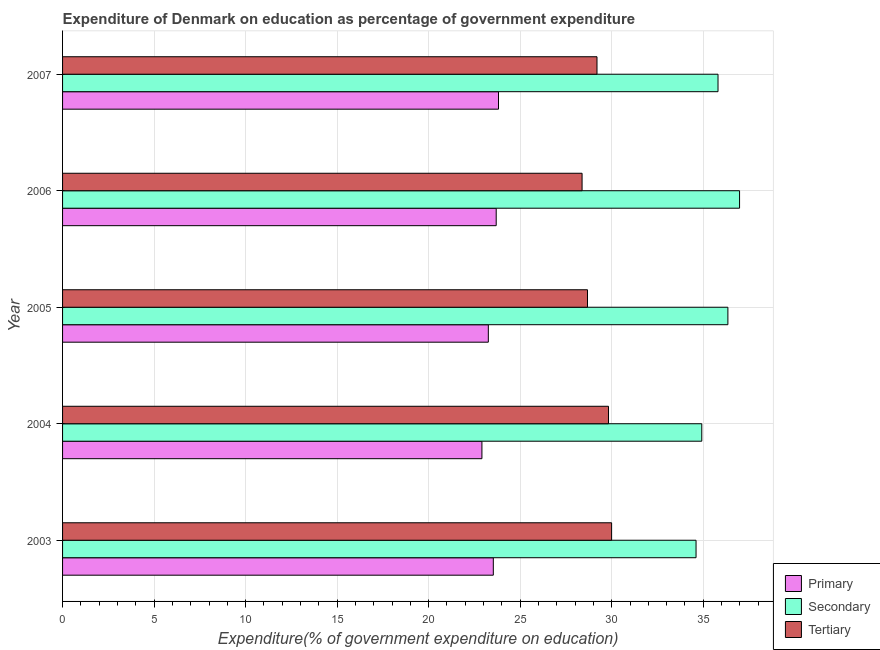Are the number of bars on each tick of the Y-axis equal?
Offer a terse response. Yes. How many bars are there on the 3rd tick from the bottom?
Give a very brief answer. 3. What is the expenditure on secondary education in 2005?
Provide a short and direct response. 36.35. Across all years, what is the maximum expenditure on primary education?
Offer a very short reply. 23.82. Across all years, what is the minimum expenditure on primary education?
Your answer should be compact. 22.91. What is the total expenditure on secondary education in the graph?
Keep it short and to the point. 178.67. What is the difference between the expenditure on secondary education in 2003 and that in 2007?
Ensure brevity in your answer.  -1.2. What is the difference between the expenditure on secondary education in 2007 and the expenditure on tertiary education in 2003?
Provide a succinct answer. 5.81. What is the average expenditure on primary education per year?
Keep it short and to the point. 23.44. In the year 2005, what is the difference between the expenditure on primary education and expenditure on secondary education?
Give a very brief answer. -13.09. In how many years, is the expenditure on primary education greater than 7 %?
Provide a succinct answer. 5. Is the expenditure on secondary education in 2003 less than that in 2005?
Provide a short and direct response. Yes. Is the difference between the expenditure on primary education in 2003 and 2004 greater than the difference between the expenditure on secondary education in 2003 and 2004?
Provide a succinct answer. Yes. What is the difference between the highest and the second highest expenditure on tertiary education?
Your answer should be very brief. 0.17. What is the difference between the highest and the lowest expenditure on secondary education?
Provide a short and direct response. 2.38. Is the sum of the expenditure on primary education in 2003 and 2006 greater than the maximum expenditure on secondary education across all years?
Offer a terse response. Yes. What does the 1st bar from the top in 2006 represents?
Your response must be concise. Tertiary. What does the 2nd bar from the bottom in 2004 represents?
Keep it short and to the point. Secondary. Is it the case that in every year, the sum of the expenditure on primary education and expenditure on secondary education is greater than the expenditure on tertiary education?
Offer a terse response. Yes. How many bars are there?
Keep it short and to the point. 15. Are all the bars in the graph horizontal?
Your answer should be compact. Yes. How many years are there in the graph?
Ensure brevity in your answer.  5. Does the graph contain grids?
Ensure brevity in your answer.  Yes. What is the title of the graph?
Your answer should be very brief. Expenditure of Denmark on education as percentage of government expenditure. Does "Liquid fuel" appear as one of the legend labels in the graph?
Your answer should be very brief. No. What is the label or title of the X-axis?
Offer a terse response. Expenditure(% of government expenditure on education). What is the label or title of the Y-axis?
Provide a short and direct response. Year. What is the Expenditure(% of government expenditure on education) of Primary in 2003?
Make the answer very short. 23.53. What is the Expenditure(% of government expenditure on education) of Secondary in 2003?
Ensure brevity in your answer.  34.61. What is the Expenditure(% of government expenditure on education) of Tertiary in 2003?
Provide a short and direct response. 30. What is the Expenditure(% of government expenditure on education) in Primary in 2004?
Your answer should be compact. 22.91. What is the Expenditure(% of government expenditure on education) of Secondary in 2004?
Provide a succinct answer. 34.92. What is the Expenditure(% of government expenditure on education) of Tertiary in 2004?
Your answer should be very brief. 29.82. What is the Expenditure(% of government expenditure on education) in Primary in 2005?
Keep it short and to the point. 23.26. What is the Expenditure(% of government expenditure on education) in Secondary in 2005?
Your answer should be very brief. 36.35. What is the Expenditure(% of government expenditure on education) of Tertiary in 2005?
Your answer should be very brief. 28.68. What is the Expenditure(% of government expenditure on education) of Primary in 2006?
Offer a very short reply. 23.69. What is the Expenditure(% of government expenditure on education) in Secondary in 2006?
Your answer should be compact. 36.99. What is the Expenditure(% of government expenditure on education) in Tertiary in 2006?
Offer a very short reply. 28.38. What is the Expenditure(% of government expenditure on education) of Primary in 2007?
Your answer should be compact. 23.82. What is the Expenditure(% of government expenditure on education) of Secondary in 2007?
Provide a succinct answer. 35.81. What is the Expenditure(% of government expenditure on education) in Tertiary in 2007?
Ensure brevity in your answer.  29.2. Across all years, what is the maximum Expenditure(% of government expenditure on education) in Primary?
Offer a terse response. 23.82. Across all years, what is the maximum Expenditure(% of government expenditure on education) of Secondary?
Offer a terse response. 36.99. Across all years, what is the maximum Expenditure(% of government expenditure on education) in Tertiary?
Offer a terse response. 30. Across all years, what is the minimum Expenditure(% of government expenditure on education) of Primary?
Offer a terse response. 22.91. Across all years, what is the minimum Expenditure(% of government expenditure on education) of Secondary?
Your response must be concise. 34.61. Across all years, what is the minimum Expenditure(% of government expenditure on education) in Tertiary?
Offer a very short reply. 28.38. What is the total Expenditure(% of government expenditure on education) of Primary in the graph?
Ensure brevity in your answer.  117.21. What is the total Expenditure(% of government expenditure on education) of Secondary in the graph?
Make the answer very short. 178.67. What is the total Expenditure(% of government expenditure on education) of Tertiary in the graph?
Your answer should be very brief. 146.08. What is the difference between the Expenditure(% of government expenditure on education) in Primary in 2003 and that in 2004?
Give a very brief answer. 0.62. What is the difference between the Expenditure(% of government expenditure on education) of Secondary in 2003 and that in 2004?
Offer a very short reply. -0.31. What is the difference between the Expenditure(% of government expenditure on education) of Tertiary in 2003 and that in 2004?
Provide a succinct answer. 0.17. What is the difference between the Expenditure(% of government expenditure on education) of Primary in 2003 and that in 2005?
Ensure brevity in your answer.  0.27. What is the difference between the Expenditure(% of government expenditure on education) of Secondary in 2003 and that in 2005?
Your answer should be very brief. -1.74. What is the difference between the Expenditure(% of government expenditure on education) of Tertiary in 2003 and that in 2005?
Provide a succinct answer. 1.32. What is the difference between the Expenditure(% of government expenditure on education) of Primary in 2003 and that in 2006?
Give a very brief answer. -0.16. What is the difference between the Expenditure(% of government expenditure on education) of Secondary in 2003 and that in 2006?
Your response must be concise. -2.38. What is the difference between the Expenditure(% of government expenditure on education) of Tertiary in 2003 and that in 2006?
Offer a terse response. 1.61. What is the difference between the Expenditure(% of government expenditure on education) of Primary in 2003 and that in 2007?
Your answer should be very brief. -0.28. What is the difference between the Expenditure(% of government expenditure on education) of Secondary in 2003 and that in 2007?
Keep it short and to the point. -1.2. What is the difference between the Expenditure(% of government expenditure on education) in Tertiary in 2003 and that in 2007?
Keep it short and to the point. 0.8. What is the difference between the Expenditure(% of government expenditure on education) of Primary in 2004 and that in 2005?
Your response must be concise. -0.35. What is the difference between the Expenditure(% of government expenditure on education) in Secondary in 2004 and that in 2005?
Your answer should be very brief. -1.43. What is the difference between the Expenditure(% of government expenditure on education) of Tertiary in 2004 and that in 2005?
Keep it short and to the point. 1.15. What is the difference between the Expenditure(% of government expenditure on education) of Primary in 2004 and that in 2006?
Your answer should be compact. -0.78. What is the difference between the Expenditure(% of government expenditure on education) of Secondary in 2004 and that in 2006?
Your answer should be very brief. -2.06. What is the difference between the Expenditure(% of government expenditure on education) in Tertiary in 2004 and that in 2006?
Keep it short and to the point. 1.44. What is the difference between the Expenditure(% of government expenditure on education) of Primary in 2004 and that in 2007?
Your answer should be very brief. -0.91. What is the difference between the Expenditure(% of government expenditure on education) of Secondary in 2004 and that in 2007?
Provide a short and direct response. -0.89. What is the difference between the Expenditure(% of government expenditure on education) of Tertiary in 2004 and that in 2007?
Provide a succinct answer. 0.63. What is the difference between the Expenditure(% of government expenditure on education) of Primary in 2005 and that in 2006?
Offer a very short reply. -0.43. What is the difference between the Expenditure(% of government expenditure on education) of Secondary in 2005 and that in 2006?
Your answer should be very brief. -0.64. What is the difference between the Expenditure(% of government expenditure on education) in Tertiary in 2005 and that in 2006?
Keep it short and to the point. 0.3. What is the difference between the Expenditure(% of government expenditure on education) in Primary in 2005 and that in 2007?
Ensure brevity in your answer.  -0.56. What is the difference between the Expenditure(% of government expenditure on education) of Secondary in 2005 and that in 2007?
Provide a succinct answer. 0.54. What is the difference between the Expenditure(% of government expenditure on education) in Tertiary in 2005 and that in 2007?
Provide a short and direct response. -0.52. What is the difference between the Expenditure(% of government expenditure on education) in Primary in 2006 and that in 2007?
Your response must be concise. -0.13. What is the difference between the Expenditure(% of government expenditure on education) of Secondary in 2006 and that in 2007?
Offer a terse response. 1.18. What is the difference between the Expenditure(% of government expenditure on education) of Tertiary in 2006 and that in 2007?
Your answer should be very brief. -0.81. What is the difference between the Expenditure(% of government expenditure on education) in Primary in 2003 and the Expenditure(% of government expenditure on education) in Secondary in 2004?
Offer a very short reply. -11.39. What is the difference between the Expenditure(% of government expenditure on education) in Primary in 2003 and the Expenditure(% of government expenditure on education) in Tertiary in 2004?
Your answer should be compact. -6.29. What is the difference between the Expenditure(% of government expenditure on education) of Secondary in 2003 and the Expenditure(% of government expenditure on education) of Tertiary in 2004?
Make the answer very short. 4.78. What is the difference between the Expenditure(% of government expenditure on education) of Primary in 2003 and the Expenditure(% of government expenditure on education) of Secondary in 2005?
Your answer should be compact. -12.81. What is the difference between the Expenditure(% of government expenditure on education) of Primary in 2003 and the Expenditure(% of government expenditure on education) of Tertiary in 2005?
Offer a terse response. -5.14. What is the difference between the Expenditure(% of government expenditure on education) of Secondary in 2003 and the Expenditure(% of government expenditure on education) of Tertiary in 2005?
Keep it short and to the point. 5.93. What is the difference between the Expenditure(% of government expenditure on education) of Primary in 2003 and the Expenditure(% of government expenditure on education) of Secondary in 2006?
Offer a very short reply. -13.45. What is the difference between the Expenditure(% of government expenditure on education) in Primary in 2003 and the Expenditure(% of government expenditure on education) in Tertiary in 2006?
Your answer should be compact. -4.85. What is the difference between the Expenditure(% of government expenditure on education) in Secondary in 2003 and the Expenditure(% of government expenditure on education) in Tertiary in 2006?
Keep it short and to the point. 6.23. What is the difference between the Expenditure(% of government expenditure on education) of Primary in 2003 and the Expenditure(% of government expenditure on education) of Secondary in 2007?
Provide a short and direct response. -12.28. What is the difference between the Expenditure(% of government expenditure on education) in Primary in 2003 and the Expenditure(% of government expenditure on education) in Tertiary in 2007?
Your answer should be very brief. -5.66. What is the difference between the Expenditure(% of government expenditure on education) of Secondary in 2003 and the Expenditure(% of government expenditure on education) of Tertiary in 2007?
Provide a short and direct response. 5.41. What is the difference between the Expenditure(% of government expenditure on education) of Primary in 2004 and the Expenditure(% of government expenditure on education) of Secondary in 2005?
Offer a very short reply. -13.44. What is the difference between the Expenditure(% of government expenditure on education) of Primary in 2004 and the Expenditure(% of government expenditure on education) of Tertiary in 2005?
Your answer should be very brief. -5.77. What is the difference between the Expenditure(% of government expenditure on education) of Secondary in 2004 and the Expenditure(% of government expenditure on education) of Tertiary in 2005?
Your answer should be compact. 6.24. What is the difference between the Expenditure(% of government expenditure on education) in Primary in 2004 and the Expenditure(% of government expenditure on education) in Secondary in 2006?
Provide a succinct answer. -14.08. What is the difference between the Expenditure(% of government expenditure on education) of Primary in 2004 and the Expenditure(% of government expenditure on education) of Tertiary in 2006?
Give a very brief answer. -5.47. What is the difference between the Expenditure(% of government expenditure on education) in Secondary in 2004 and the Expenditure(% of government expenditure on education) in Tertiary in 2006?
Your answer should be very brief. 6.54. What is the difference between the Expenditure(% of government expenditure on education) in Primary in 2004 and the Expenditure(% of government expenditure on education) in Secondary in 2007?
Make the answer very short. -12.9. What is the difference between the Expenditure(% of government expenditure on education) of Primary in 2004 and the Expenditure(% of government expenditure on education) of Tertiary in 2007?
Offer a very short reply. -6.29. What is the difference between the Expenditure(% of government expenditure on education) of Secondary in 2004 and the Expenditure(% of government expenditure on education) of Tertiary in 2007?
Give a very brief answer. 5.72. What is the difference between the Expenditure(% of government expenditure on education) in Primary in 2005 and the Expenditure(% of government expenditure on education) in Secondary in 2006?
Your answer should be very brief. -13.73. What is the difference between the Expenditure(% of government expenditure on education) in Primary in 2005 and the Expenditure(% of government expenditure on education) in Tertiary in 2006?
Your response must be concise. -5.12. What is the difference between the Expenditure(% of government expenditure on education) of Secondary in 2005 and the Expenditure(% of government expenditure on education) of Tertiary in 2006?
Your answer should be compact. 7.97. What is the difference between the Expenditure(% of government expenditure on education) in Primary in 2005 and the Expenditure(% of government expenditure on education) in Secondary in 2007?
Offer a terse response. -12.55. What is the difference between the Expenditure(% of government expenditure on education) of Primary in 2005 and the Expenditure(% of government expenditure on education) of Tertiary in 2007?
Offer a terse response. -5.94. What is the difference between the Expenditure(% of government expenditure on education) in Secondary in 2005 and the Expenditure(% of government expenditure on education) in Tertiary in 2007?
Offer a terse response. 7.15. What is the difference between the Expenditure(% of government expenditure on education) in Primary in 2006 and the Expenditure(% of government expenditure on education) in Secondary in 2007?
Provide a succinct answer. -12.12. What is the difference between the Expenditure(% of government expenditure on education) of Primary in 2006 and the Expenditure(% of government expenditure on education) of Tertiary in 2007?
Your answer should be very brief. -5.51. What is the difference between the Expenditure(% of government expenditure on education) of Secondary in 2006 and the Expenditure(% of government expenditure on education) of Tertiary in 2007?
Your answer should be very brief. 7.79. What is the average Expenditure(% of government expenditure on education) of Primary per year?
Offer a very short reply. 23.44. What is the average Expenditure(% of government expenditure on education) of Secondary per year?
Your answer should be very brief. 35.73. What is the average Expenditure(% of government expenditure on education) of Tertiary per year?
Offer a very short reply. 29.22. In the year 2003, what is the difference between the Expenditure(% of government expenditure on education) of Primary and Expenditure(% of government expenditure on education) of Secondary?
Give a very brief answer. -11.08. In the year 2003, what is the difference between the Expenditure(% of government expenditure on education) in Primary and Expenditure(% of government expenditure on education) in Tertiary?
Your response must be concise. -6.46. In the year 2003, what is the difference between the Expenditure(% of government expenditure on education) in Secondary and Expenditure(% of government expenditure on education) in Tertiary?
Ensure brevity in your answer.  4.61. In the year 2004, what is the difference between the Expenditure(% of government expenditure on education) of Primary and Expenditure(% of government expenditure on education) of Secondary?
Your response must be concise. -12.01. In the year 2004, what is the difference between the Expenditure(% of government expenditure on education) in Primary and Expenditure(% of government expenditure on education) in Tertiary?
Your answer should be very brief. -6.91. In the year 2004, what is the difference between the Expenditure(% of government expenditure on education) in Secondary and Expenditure(% of government expenditure on education) in Tertiary?
Provide a short and direct response. 5.1. In the year 2005, what is the difference between the Expenditure(% of government expenditure on education) in Primary and Expenditure(% of government expenditure on education) in Secondary?
Your answer should be very brief. -13.09. In the year 2005, what is the difference between the Expenditure(% of government expenditure on education) of Primary and Expenditure(% of government expenditure on education) of Tertiary?
Your answer should be compact. -5.42. In the year 2005, what is the difference between the Expenditure(% of government expenditure on education) of Secondary and Expenditure(% of government expenditure on education) of Tertiary?
Your answer should be very brief. 7.67. In the year 2006, what is the difference between the Expenditure(% of government expenditure on education) in Primary and Expenditure(% of government expenditure on education) in Secondary?
Give a very brief answer. -13.3. In the year 2006, what is the difference between the Expenditure(% of government expenditure on education) in Primary and Expenditure(% of government expenditure on education) in Tertiary?
Provide a short and direct response. -4.69. In the year 2006, what is the difference between the Expenditure(% of government expenditure on education) in Secondary and Expenditure(% of government expenditure on education) in Tertiary?
Provide a short and direct response. 8.6. In the year 2007, what is the difference between the Expenditure(% of government expenditure on education) in Primary and Expenditure(% of government expenditure on education) in Secondary?
Ensure brevity in your answer.  -11.99. In the year 2007, what is the difference between the Expenditure(% of government expenditure on education) in Primary and Expenditure(% of government expenditure on education) in Tertiary?
Provide a succinct answer. -5.38. In the year 2007, what is the difference between the Expenditure(% of government expenditure on education) of Secondary and Expenditure(% of government expenditure on education) of Tertiary?
Offer a terse response. 6.61. What is the ratio of the Expenditure(% of government expenditure on education) in Primary in 2003 to that in 2004?
Provide a succinct answer. 1.03. What is the ratio of the Expenditure(% of government expenditure on education) of Primary in 2003 to that in 2005?
Provide a succinct answer. 1.01. What is the ratio of the Expenditure(% of government expenditure on education) of Secondary in 2003 to that in 2005?
Ensure brevity in your answer.  0.95. What is the ratio of the Expenditure(% of government expenditure on education) of Tertiary in 2003 to that in 2005?
Provide a succinct answer. 1.05. What is the ratio of the Expenditure(% of government expenditure on education) in Primary in 2003 to that in 2006?
Your response must be concise. 0.99. What is the ratio of the Expenditure(% of government expenditure on education) in Secondary in 2003 to that in 2006?
Make the answer very short. 0.94. What is the ratio of the Expenditure(% of government expenditure on education) in Tertiary in 2003 to that in 2006?
Your answer should be very brief. 1.06. What is the ratio of the Expenditure(% of government expenditure on education) in Secondary in 2003 to that in 2007?
Provide a succinct answer. 0.97. What is the ratio of the Expenditure(% of government expenditure on education) in Tertiary in 2003 to that in 2007?
Ensure brevity in your answer.  1.03. What is the ratio of the Expenditure(% of government expenditure on education) in Primary in 2004 to that in 2005?
Your response must be concise. 0.98. What is the ratio of the Expenditure(% of government expenditure on education) in Secondary in 2004 to that in 2005?
Your answer should be compact. 0.96. What is the ratio of the Expenditure(% of government expenditure on education) in Tertiary in 2004 to that in 2005?
Your answer should be very brief. 1.04. What is the ratio of the Expenditure(% of government expenditure on education) of Primary in 2004 to that in 2006?
Ensure brevity in your answer.  0.97. What is the ratio of the Expenditure(% of government expenditure on education) of Secondary in 2004 to that in 2006?
Offer a terse response. 0.94. What is the ratio of the Expenditure(% of government expenditure on education) of Tertiary in 2004 to that in 2006?
Offer a very short reply. 1.05. What is the ratio of the Expenditure(% of government expenditure on education) of Primary in 2004 to that in 2007?
Provide a short and direct response. 0.96. What is the ratio of the Expenditure(% of government expenditure on education) of Secondary in 2004 to that in 2007?
Your response must be concise. 0.98. What is the ratio of the Expenditure(% of government expenditure on education) in Tertiary in 2004 to that in 2007?
Make the answer very short. 1.02. What is the ratio of the Expenditure(% of government expenditure on education) in Primary in 2005 to that in 2006?
Provide a succinct answer. 0.98. What is the ratio of the Expenditure(% of government expenditure on education) in Secondary in 2005 to that in 2006?
Your answer should be compact. 0.98. What is the ratio of the Expenditure(% of government expenditure on education) in Tertiary in 2005 to that in 2006?
Provide a short and direct response. 1.01. What is the ratio of the Expenditure(% of government expenditure on education) in Primary in 2005 to that in 2007?
Offer a terse response. 0.98. What is the ratio of the Expenditure(% of government expenditure on education) in Secondary in 2005 to that in 2007?
Provide a short and direct response. 1.02. What is the ratio of the Expenditure(% of government expenditure on education) in Tertiary in 2005 to that in 2007?
Offer a terse response. 0.98. What is the ratio of the Expenditure(% of government expenditure on education) in Secondary in 2006 to that in 2007?
Your answer should be compact. 1.03. What is the ratio of the Expenditure(% of government expenditure on education) in Tertiary in 2006 to that in 2007?
Your answer should be very brief. 0.97. What is the difference between the highest and the second highest Expenditure(% of government expenditure on education) in Primary?
Keep it short and to the point. 0.13. What is the difference between the highest and the second highest Expenditure(% of government expenditure on education) in Secondary?
Make the answer very short. 0.64. What is the difference between the highest and the second highest Expenditure(% of government expenditure on education) of Tertiary?
Your response must be concise. 0.17. What is the difference between the highest and the lowest Expenditure(% of government expenditure on education) of Primary?
Make the answer very short. 0.91. What is the difference between the highest and the lowest Expenditure(% of government expenditure on education) of Secondary?
Your answer should be very brief. 2.38. What is the difference between the highest and the lowest Expenditure(% of government expenditure on education) of Tertiary?
Ensure brevity in your answer.  1.61. 